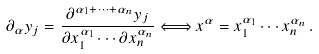<formula> <loc_0><loc_0><loc_500><loc_500>\partial _ { \alpha } y _ { j } = \frac { \partial ^ { \alpha _ { 1 } + \cdots + \alpha _ { n } } y _ { j } } { \partial x _ { 1 } ^ { \alpha _ { 1 } } \cdots \partial x _ { n } ^ { \alpha _ { n } } } \Longleftrightarrow x ^ { \alpha } = x _ { 1 } ^ { \alpha _ { 1 } } \cdots x _ { n } ^ { \alpha _ { n } } \, .</formula> 